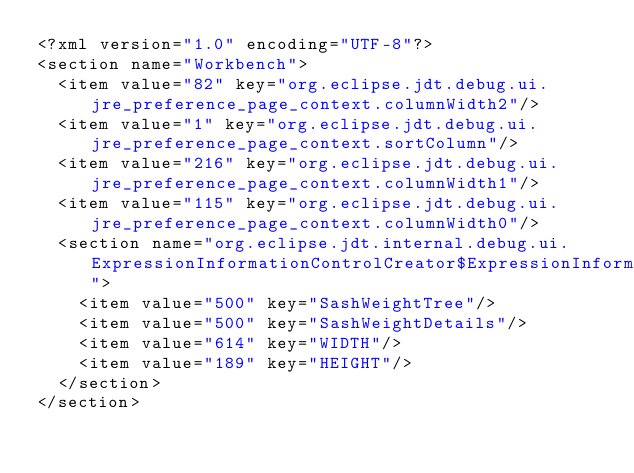<code> <loc_0><loc_0><loc_500><loc_500><_XML_><?xml version="1.0" encoding="UTF-8"?>
<section name="Workbench">
	<item value="82" key="org.eclipse.jdt.debug.ui.jre_preference_page_context.columnWidth2"/>
	<item value="1" key="org.eclipse.jdt.debug.ui.jre_preference_page_context.sortColumn"/>
	<item value="216" key="org.eclipse.jdt.debug.ui.jre_preference_page_context.columnWidth1"/>
	<item value="115" key="org.eclipse.jdt.debug.ui.jre_preference_page_context.columnWidth0"/>
	<section name="org.eclipse.jdt.internal.debug.ui.ExpressionInformationControlCreator$ExpressionInformationControl">
		<item value="500" key="SashWeightTree"/>
		<item value="500" key="SashWeightDetails"/>
		<item value="614" key="WIDTH"/>
		<item value="189" key="HEIGHT"/>
	</section>
</section>
</code> 